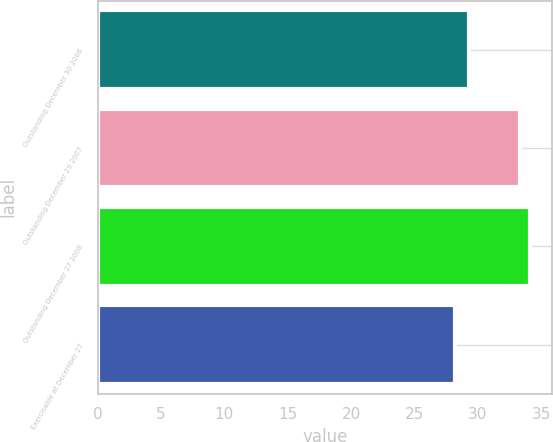Convert chart. <chart><loc_0><loc_0><loc_500><loc_500><bar_chart><fcel>Outstanding December 30 2006<fcel>Outstanding December 29 2007<fcel>Outstanding December 27 2008<fcel>Exercisable at December 27<nl><fcel>29.32<fcel>33.31<fcel>34.14<fcel>28.23<nl></chart> 